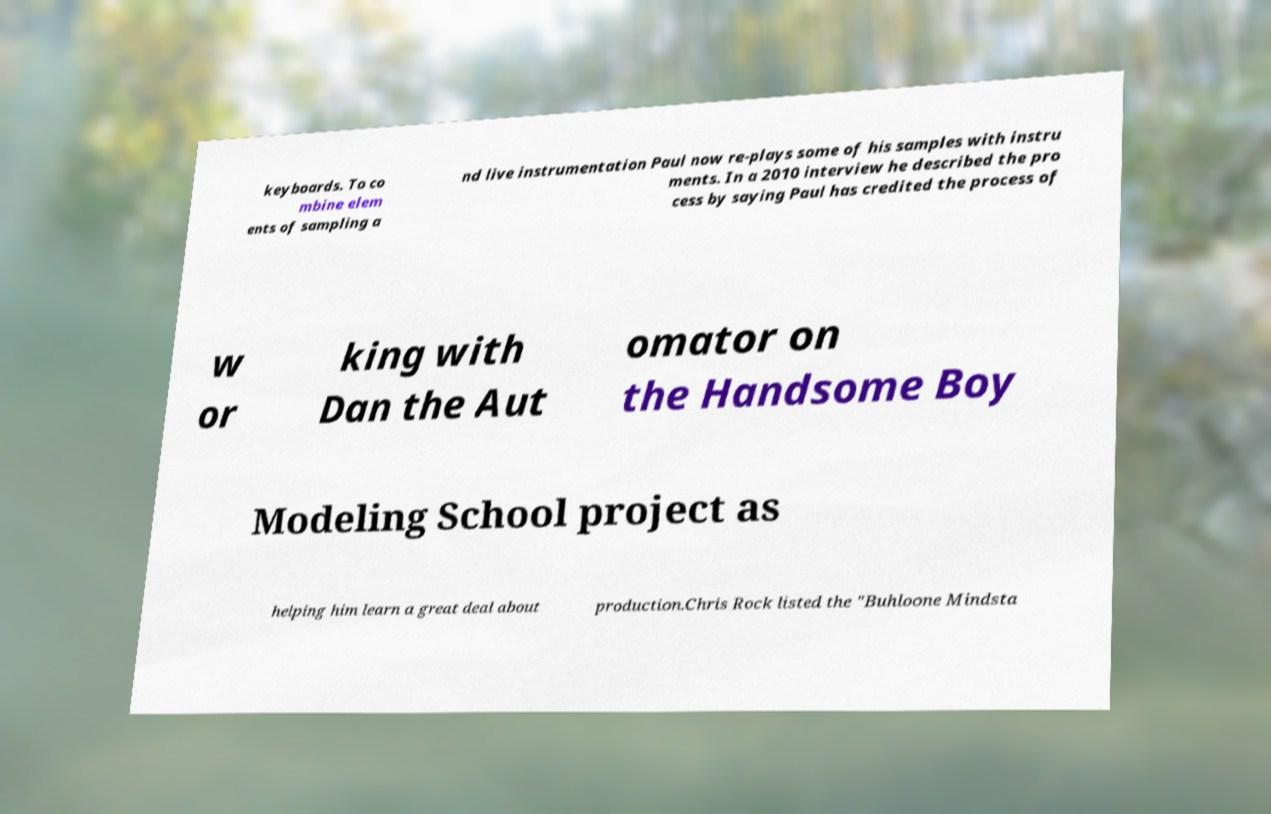For documentation purposes, I need the text within this image transcribed. Could you provide that? keyboards. To co mbine elem ents of sampling a nd live instrumentation Paul now re-plays some of his samples with instru ments. In a 2010 interview he described the pro cess by saying Paul has credited the process of w or king with Dan the Aut omator on the Handsome Boy Modeling School project as helping him learn a great deal about production.Chris Rock listed the "Buhloone Mindsta 